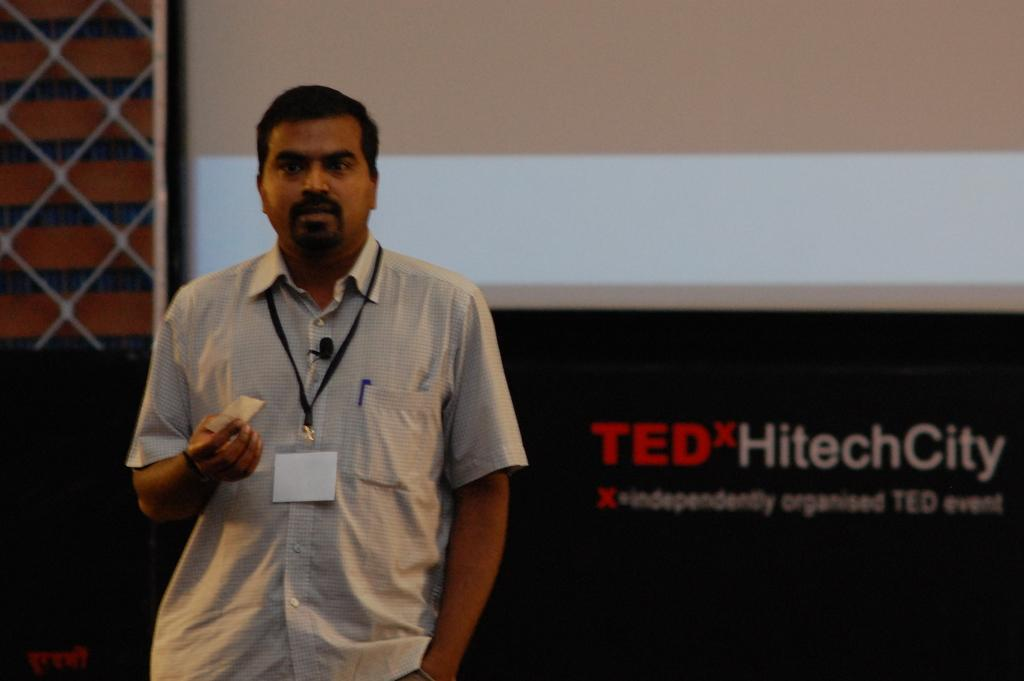Who is present in the image? There is a person in the image. What is the person doing in the image? The person is standing in the image. What is the person holding in the image? The person is holding some papers in the image. What can be seen in the background of the image? There is a screen and a banner in the background of the image. What type of jewel can be seen on the person's clothing in the image? There is no jewel visible on the person's clothing in the image. What type of lace is used to decorate the screen in the background? There is no lace present on the screen in the background of the image. 